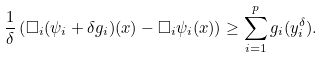<formula> <loc_0><loc_0><loc_500><loc_500>\frac { 1 } { \delta } \left ( \Box _ { i } ( \psi _ { i } + \delta g _ { i } ) ( x ) - \Box _ { i } \psi _ { i } ( x ) \right ) \geq \sum _ { i = 1 } ^ { p } g _ { i } ( y _ { i } ^ { \delta } ) .</formula> 